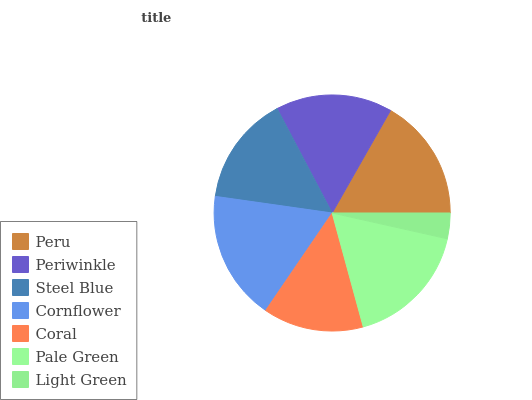Is Light Green the minimum?
Answer yes or no. Yes. Is Cornflower the maximum?
Answer yes or no. Yes. Is Periwinkle the minimum?
Answer yes or no. No. Is Periwinkle the maximum?
Answer yes or no. No. Is Peru greater than Periwinkle?
Answer yes or no. Yes. Is Periwinkle less than Peru?
Answer yes or no. Yes. Is Periwinkle greater than Peru?
Answer yes or no. No. Is Peru less than Periwinkle?
Answer yes or no. No. Is Periwinkle the high median?
Answer yes or no. Yes. Is Periwinkle the low median?
Answer yes or no. Yes. Is Steel Blue the high median?
Answer yes or no. No. Is Pale Green the low median?
Answer yes or no. No. 